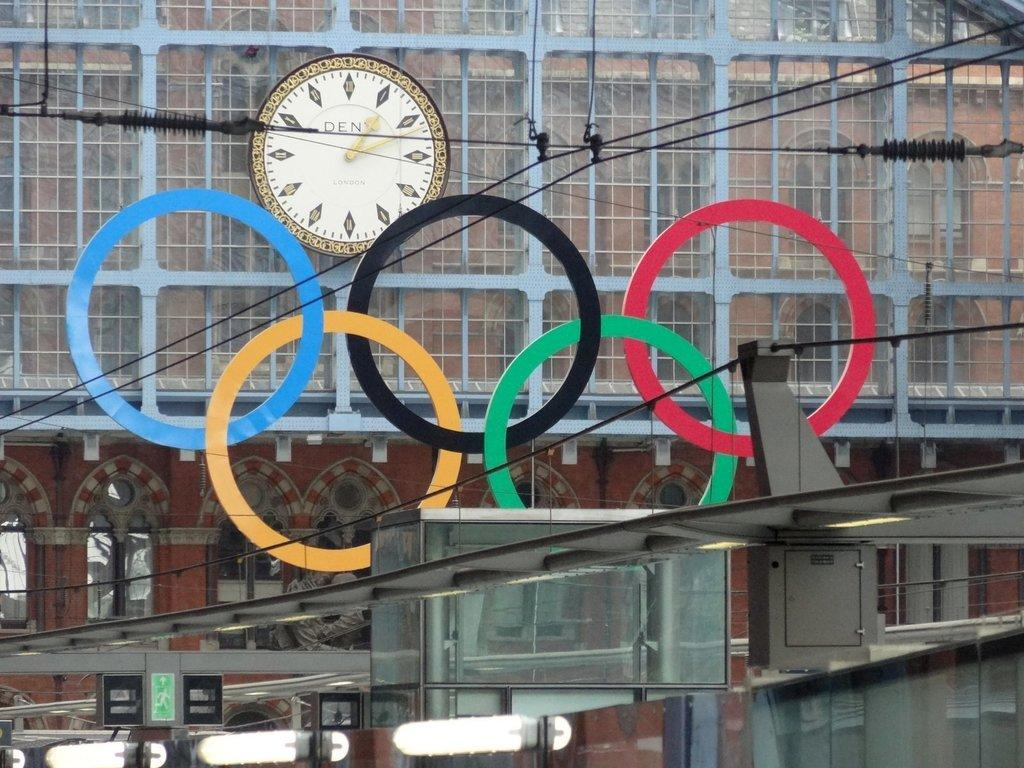<image>
Render a clear and concise summary of the photo. A large clock is mounted on the side of a building and on the face of the clock the letters DEN are printed on the face. 